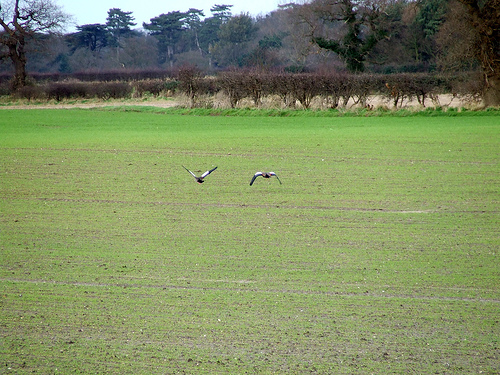<image>
Is there a bird on the field? No. The bird is not positioned on the field. They may be near each other, but the bird is not supported by or resting on top of the field. 